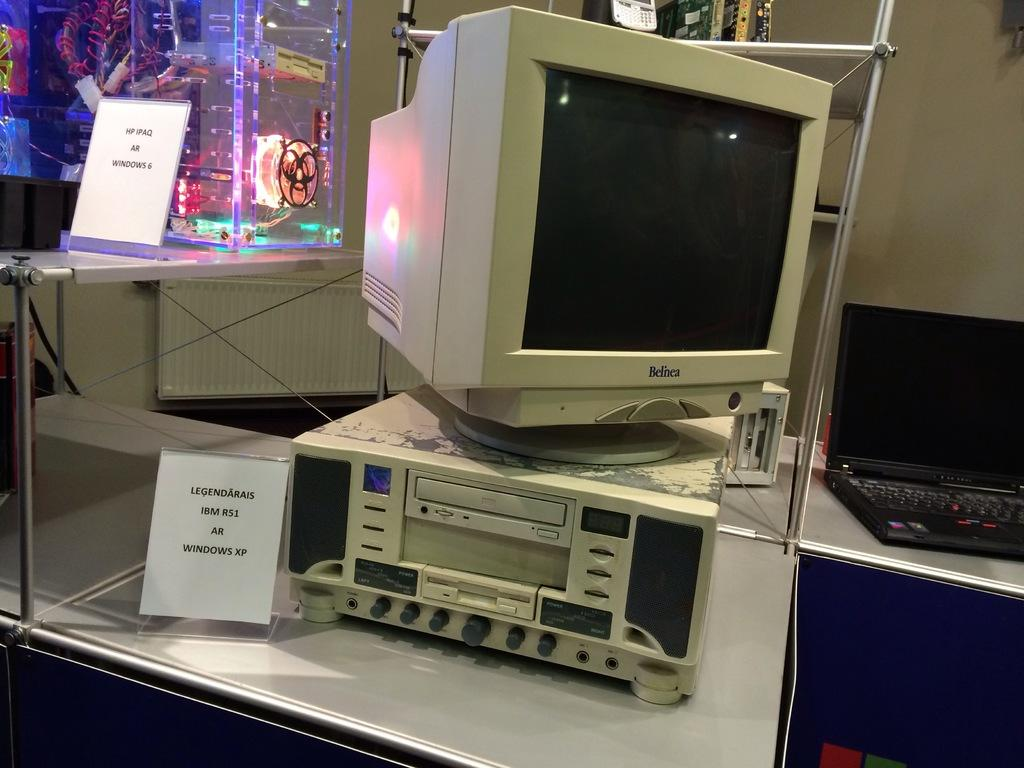<image>
Create a compact narrative representing the image presented. The computer on display is from the company Belnea.. 